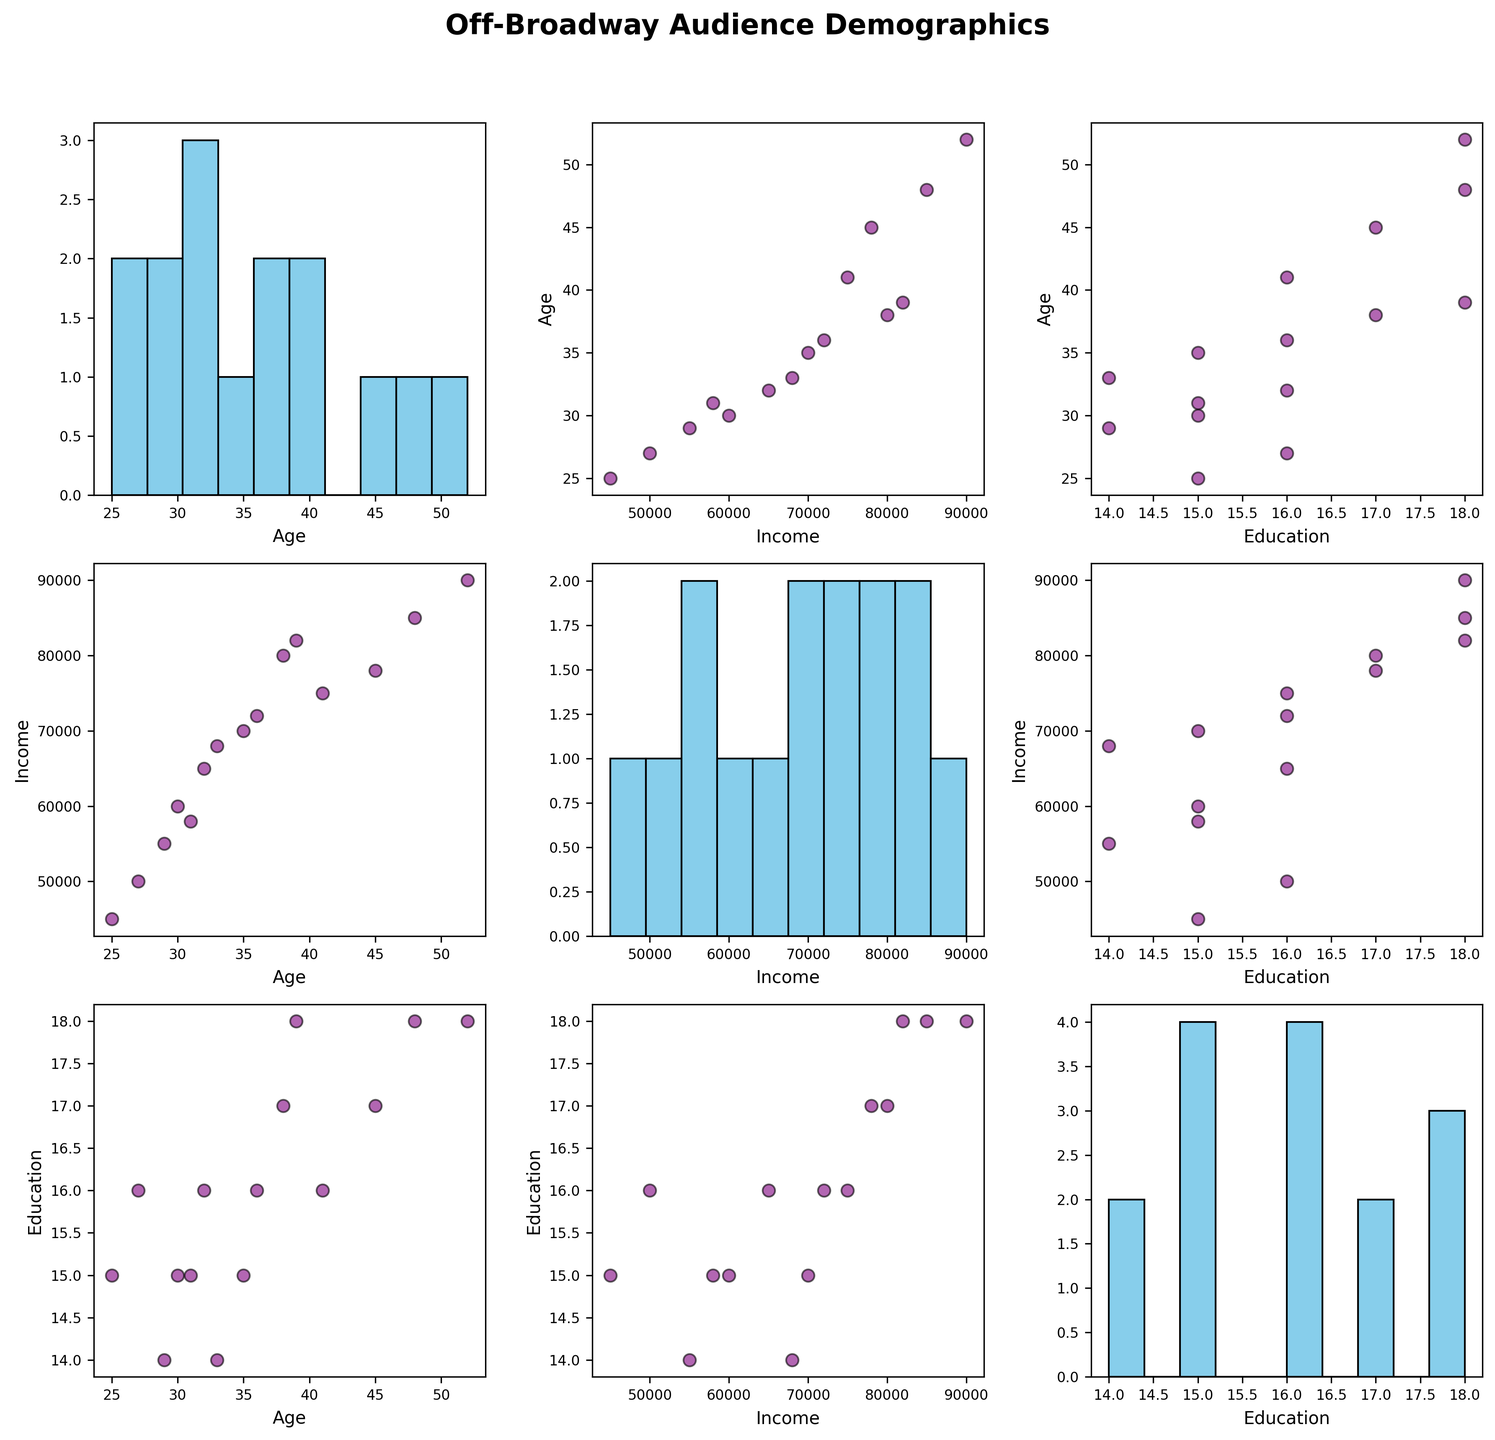what is the title of the plot? The title is displayed at the top of the plot and summarizes the overall subject of the figure. In this case, it reads 'Off-Broadway Audience Demographics'.
Answer: Off-Broadway Audience Demographics How many variables are represented in this scatterplot matrix? Each variable has its own row and column. Here, we have three variables: Age, Income, and Education.
Answer: 3 Which plot shows the distribution of the 'Income' variable? The histograms along the diagonal show the distributions of individual variables. The third plot in the second row (Income vs. Income) is where 'Income' distribution is displayed.
Answer: The third plot in the second row What is the common color used for the scatter plots in the figure? From visual inspection, all scatter plots use a purple color with black edges to represent the data points.
Answer: Purple with black edges Which variable appears to have the most spread in its distribution based on the histograms? By observing the histograms along the diagonal, 'Age' seems to have the widest spread, indicating a more significant variation in age among the audience.
Answer: Age Does there seem to be a positive correlation between 'Age' and 'Income'? By looking at the scatter plot between 'Age' and 'Income', we can see an upward trend, which indicates a positive correlation.
Answer: Yes Is there any outlier data in the 'Age vs. Education' scatter plot? By examining the scatter plot for 'Age' vs. 'Education', identify points that deviate significantly from the overall pattern.
Answer: Yes Which two variables has the strongest correlation? By observing the scatter plots, 'Age' and 'Income' demonstrate the most consistent upward trend, implying the strongest correlation.
Answer: Age and Income What is the approximate median age of the audience? From the histogram for 'Age', locate the center of the distribution. The median age appears to be around the middle of the peak.
Answer: Approximately 35 Which show has the highest income among its audience? By referencing the data point with the highest position in the 'Income' histograms and cross-referencing with the corresponding data table, we identify the show.
Answer: Perfect Crime 